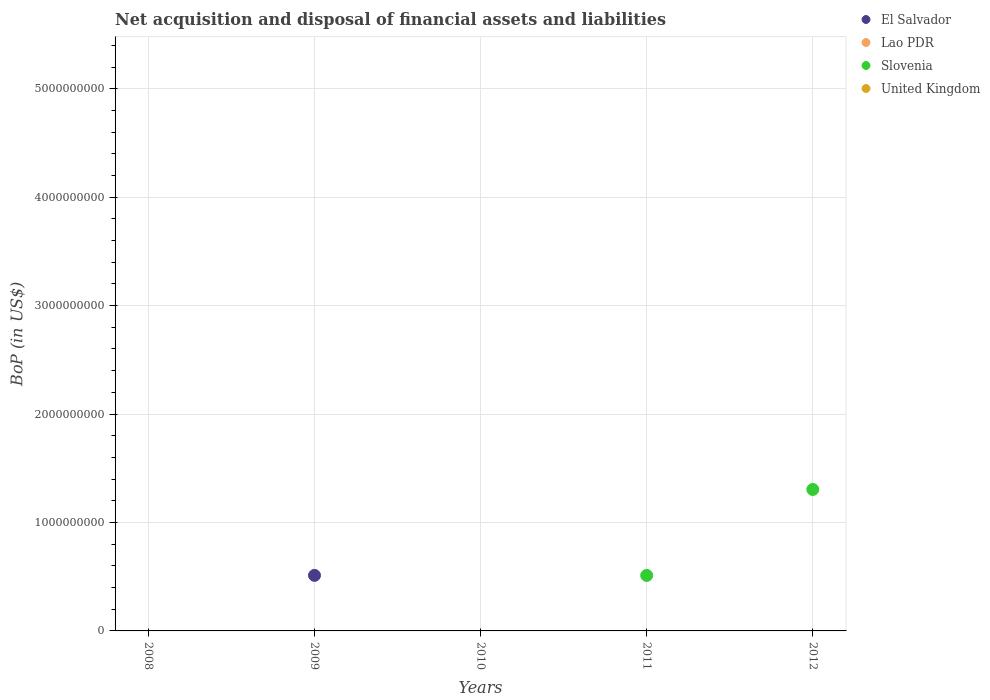What is the Balance of Payments in United Kingdom in 2008?
Give a very brief answer. 0. Across all years, what is the maximum Balance of Payments in El Salvador?
Offer a very short reply. 5.12e+08. In which year was the Balance of Payments in Slovenia maximum?
Your response must be concise. 2012. What is the average Balance of Payments in Slovenia per year?
Offer a very short reply. 3.63e+08. What is the difference between the highest and the lowest Balance of Payments in Slovenia?
Keep it short and to the point. 1.30e+09. In how many years, is the Balance of Payments in El Salvador greater than the average Balance of Payments in El Salvador taken over all years?
Your response must be concise. 1. Is it the case that in every year, the sum of the Balance of Payments in United Kingdom and Balance of Payments in Slovenia  is greater than the Balance of Payments in El Salvador?
Your answer should be compact. No. Is the Balance of Payments in United Kingdom strictly less than the Balance of Payments in Lao PDR over the years?
Give a very brief answer. Yes. What is the difference between two consecutive major ticks on the Y-axis?
Make the answer very short. 1.00e+09. Does the graph contain grids?
Keep it short and to the point. Yes. Where does the legend appear in the graph?
Your answer should be very brief. Top right. How many legend labels are there?
Keep it short and to the point. 4. What is the title of the graph?
Provide a short and direct response. Net acquisition and disposal of financial assets and liabilities. What is the label or title of the X-axis?
Your response must be concise. Years. What is the label or title of the Y-axis?
Make the answer very short. BoP (in US$). What is the BoP (in US$) in Lao PDR in 2008?
Your answer should be compact. 0. What is the BoP (in US$) in Slovenia in 2008?
Provide a succinct answer. 0. What is the BoP (in US$) of El Salvador in 2009?
Your answer should be compact. 5.12e+08. What is the BoP (in US$) in Slovenia in 2009?
Your answer should be very brief. 0. What is the BoP (in US$) in United Kingdom in 2009?
Ensure brevity in your answer.  0. What is the BoP (in US$) in Slovenia in 2010?
Your answer should be compact. 0. What is the BoP (in US$) in El Salvador in 2011?
Offer a very short reply. 0. What is the BoP (in US$) of Slovenia in 2011?
Offer a terse response. 5.12e+08. What is the BoP (in US$) of United Kingdom in 2011?
Provide a short and direct response. 0. What is the BoP (in US$) of Slovenia in 2012?
Your response must be concise. 1.30e+09. Across all years, what is the maximum BoP (in US$) in El Salvador?
Make the answer very short. 5.12e+08. Across all years, what is the maximum BoP (in US$) in Slovenia?
Give a very brief answer. 1.30e+09. Across all years, what is the minimum BoP (in US$) in Slovenia?
Ensure brevity in your answer.  0. What is the total BoP (in US$) in El Salvador in the graph?
Give a very brief answer. 5.12e+08. What is the total BoP (in US$) in Lao PDR in the graph?
Keep it short and to the point. 0. What is the total BoP (in US$) of Slovenia in the graph?
Your response must be concise. 1.82e+09. What is the total BoP (in US$) in United Kingdom in the graph?
Offer a terse response. 0. What is the difference between the BoP (in US$) of Slovenia in 2011 and that in 2012?
Offer a very short reply. -7.93e+08. What is the difference between the BoP (in US$) of El Salvador in 2009 and the BoP (in US$) of Slovenia in 2011?
Ensure brevity in your answer.  6.63e+05. What is the difference between the BoP (in US$) in El Salvador in 2009 and the BoP (in US$) in Slovenia in 2012?
Ensure brevity in your answer.  -7.92e+08. What is the average BoP (in US$) in El Salvador per year?
Give a very brief answer. 1.02e+08. What is the average BoP (in US$) of Lao PDR per year?
Your answer should be very brief. 0. What is the average BoP (in US$) of Slovenia per year?
Your answer should be compact. 3.63e+08. What is the ratio of the BoP (in US$) of Slovenia in 2011 to that in 2012?
Your answer should be compact. 0.39. What is the difference between the highest and the lowest BoP (in US$) of El Salvador?
Provide a succinct answer. 5.12e+08. What is the difference between the highest and the lowest BoP (in US$) of Slovenia?
Your answer should be very brief. 1.30e+09. 